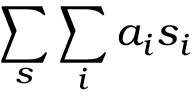<formula> <loc_0><loc_0><loc_500><loc_500>\sum _ { s } \sum _ { i } a _ { i } s _ { i }</formula> 